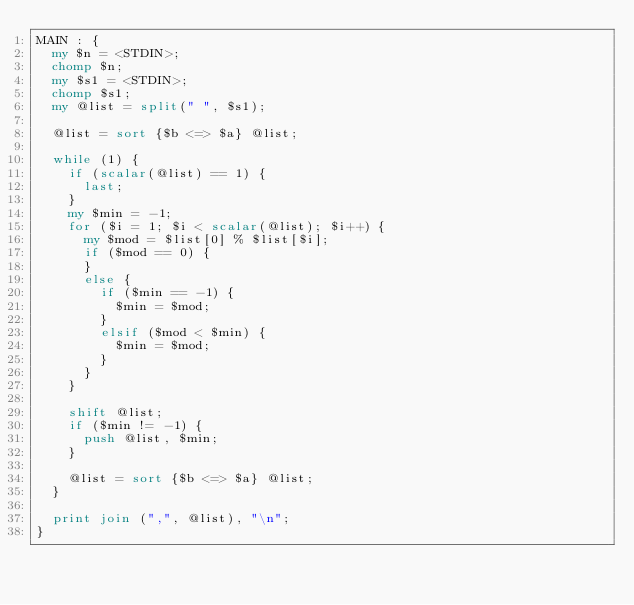<code> <loc_0><loc_0><loc_500><loc_500><_Perl_>MAIN : {
	my $n = <STDIN>;
	chomp $n;
	my $s1 = <STDIN>;
	chomp $s1;
	my @list = split(" ", $s1);
	
	@list = sort {$b <=> $a} @list;

	while (1) {
		if (scalar(@list) == 1) {
			last;
		}
		my $min = -1;
		for ($i = 1; $i < scalar(@list); $i++) {
			my $mod = $list[0] % $list[$i];
			if ($mod == 0) {
			}
			else {
				if ($min == -1) {
					$min = $mod;
				}
				elsif ($mod < $min) {
					$min = $mod;
				}
			}
		}
		
		shift @list;
		if ($min != -1) {
			push @list, $min;
		}
		
		@list = sort {$b <=> $a} @list;
	}
	
	print join (",", @list), "\n";
}



</code> 